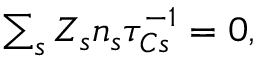<formula> <loc_0><loc_0><loc_500><loc_500>\begin{array} { r } { \sum _ { s } Z _ { s } n _ { s } \tau _ { C s } ^ { - 1 } = 0 , } \end{array}</formula> 